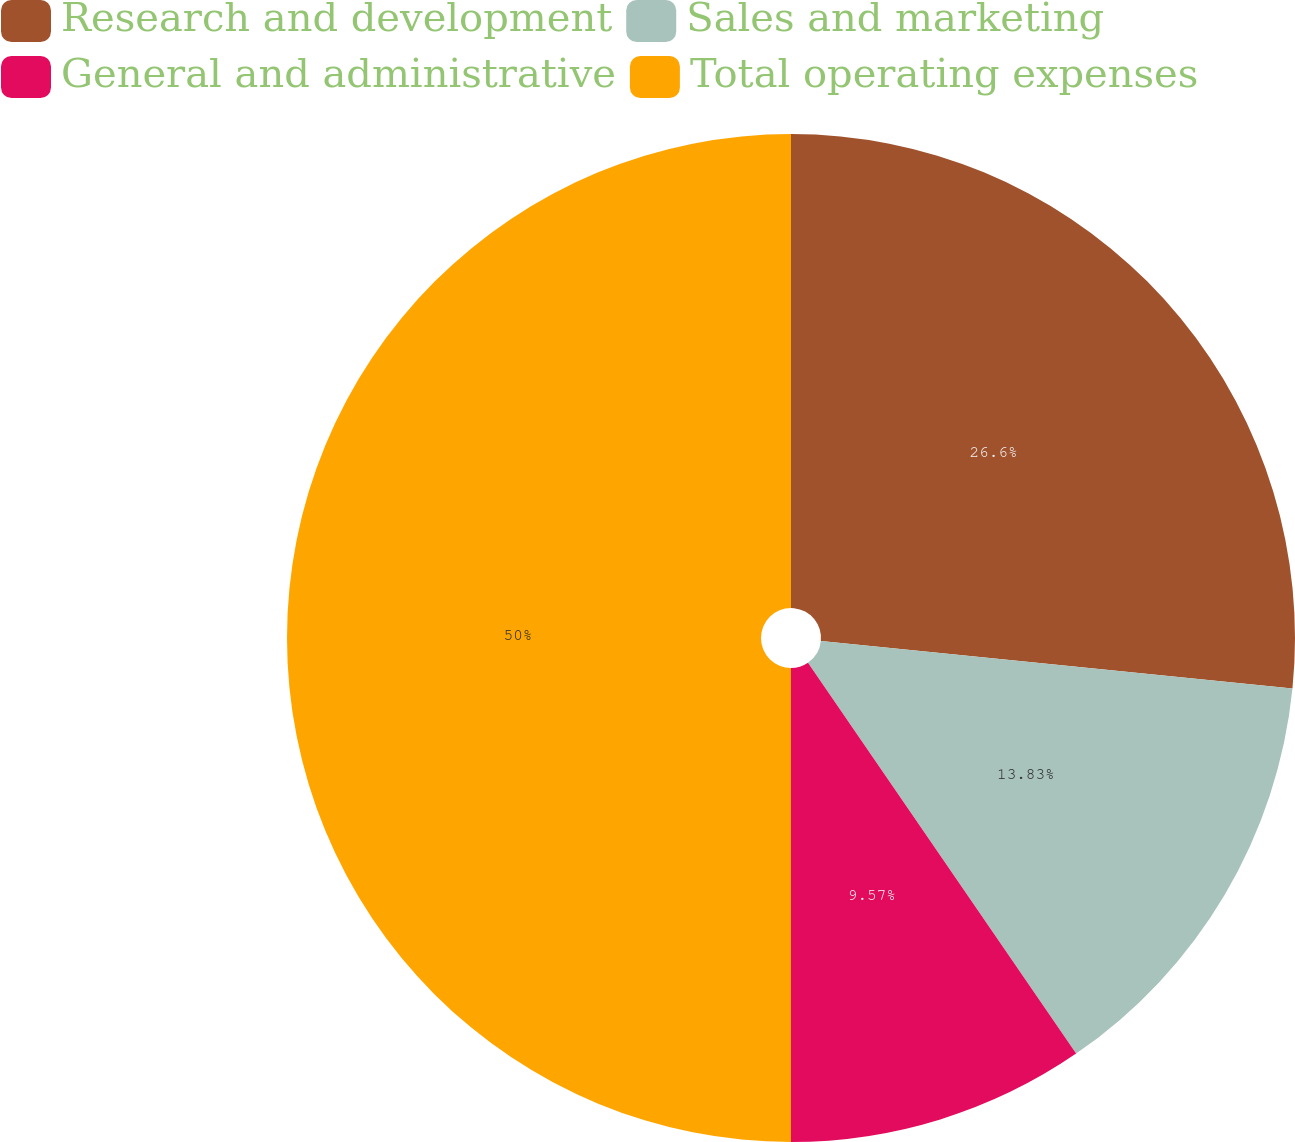<chart> <loc_0><loc_0><loc_500><loc_500><pie_chart><fcel>Research and development<fcel>Sales and marketing<fcel>General and administrative<fcel>Total operating expenses<nl><fcel>26.6%<fcel>13.83%<fcel>9.57%<fcel>50.0%<nl></chart> 